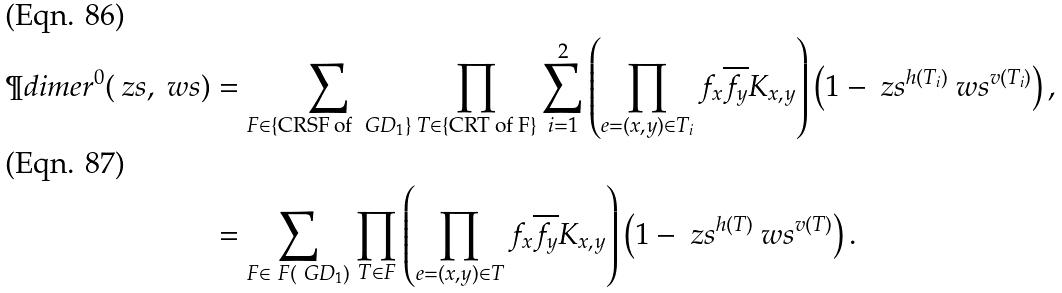Convert formula to latex. <formula><loc_0><loc_0><loc_500><loc_500>\P d i m e r ^ { 0 } ( \ z s , \ w s ) & = \sum _ { F \in \{ \text {CRSF of } \ G D _ { 1 } \} } \prod _ { T \in \{ \text {CRT of F} \} } \sum _ { i = 1 } ^ { 2 } \left ( \prod _ { e = ( x , y ) \in T _ { i } } f _ { x } \overline { f _ { y } } K _ { x , y } \right ) \left ( 1 - \ z s ^ { h ( T _ { i } ) } \ w s ^ { v ( T _ { i } ) } \right ) , \\ & = \sum _ { F \in \ F ( \ G D _ { 1 } ) } \prod _ { T \in F } \left ( \prod _ { e = ( x , y ) \in T } f _ { x } \overline { f _ { y } } K _ { x , y } \right ) \left ( 1 - \ z s ^ { h ( T ) } \ w s ^ { v ( T ) } \right ) .</formula> 